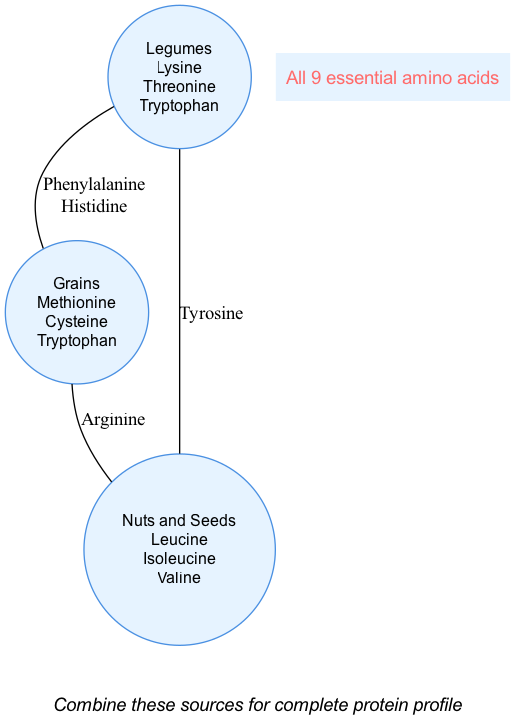What are the essential amino acids found in legumes? By observing the circle labeled "Legumes," we can see the amino acids listed there, which are Lysine, Threonine, and Tryptophan.
Answer: Lysine, Threonine, Tryptophan Which two protein sources share the amino acid Tryptophan? The diagram shows that Tryptophan is listed under both the "Legumes" and "Grains" circles, indicating that both of these sources contain Tryptophan.
Answer: Legumes and Grains How many essential amino acids are found in the overlapping area of all three protein sources? The center of the diagram indicates that the overlapping area of Legumes, Grains, and Nuts and Seeds contains all 9 essential amino acids, so we count that as one category in that region.
Answer: All 9 essential amino acids What is the unique amino acid found only in nuts and seeds? Looking at the "Nuts and Seeds" circle exclusively, we identify that there are no unique amino acids listed for that category itself, but the ones listed aside from the overlaps are Leucine, Isoleucine, and Valine. Thus, no single unique amino acid stands out from nuts and seeds relative to overlaps.
Answer: None Which two amino acids do legumes and grains have in common, aside from the unique ones they list? The overlapping area between "Legumes" and "Grains" identifies Phenylalanine and Histidine, as these are located in the region where these two circles intersect.
Answer: Phenylalanine, Histidine In total, how many different amino acids are represented in the diagram? To find the total unique amino acids, we count those in each circle and the intersections. The unique ones are 3 from Legumes + 3 from Grains + 3 from Nuts and Seeds + the overlaps. This results in 9 distinct amino acids visible in the diagram.
Answer: 9 Which amino acid is shared by grains and nuts and seeds only? The diagram indicates that Arginine is found exclusively in the overlapping area between "Grains" and "Nuts and Seeds," highlighting a unique communal contribution of this amino acid to these sources.
Answer: Arginine What should one do to achieve a complete protein profile according to the note? The note at the bottom of the diagram recommends combining the various sources, which will allow for the intake of all essential amino acids in a complete way, integrating them effectively.
Answer: Combine these sources for complete protein profile 